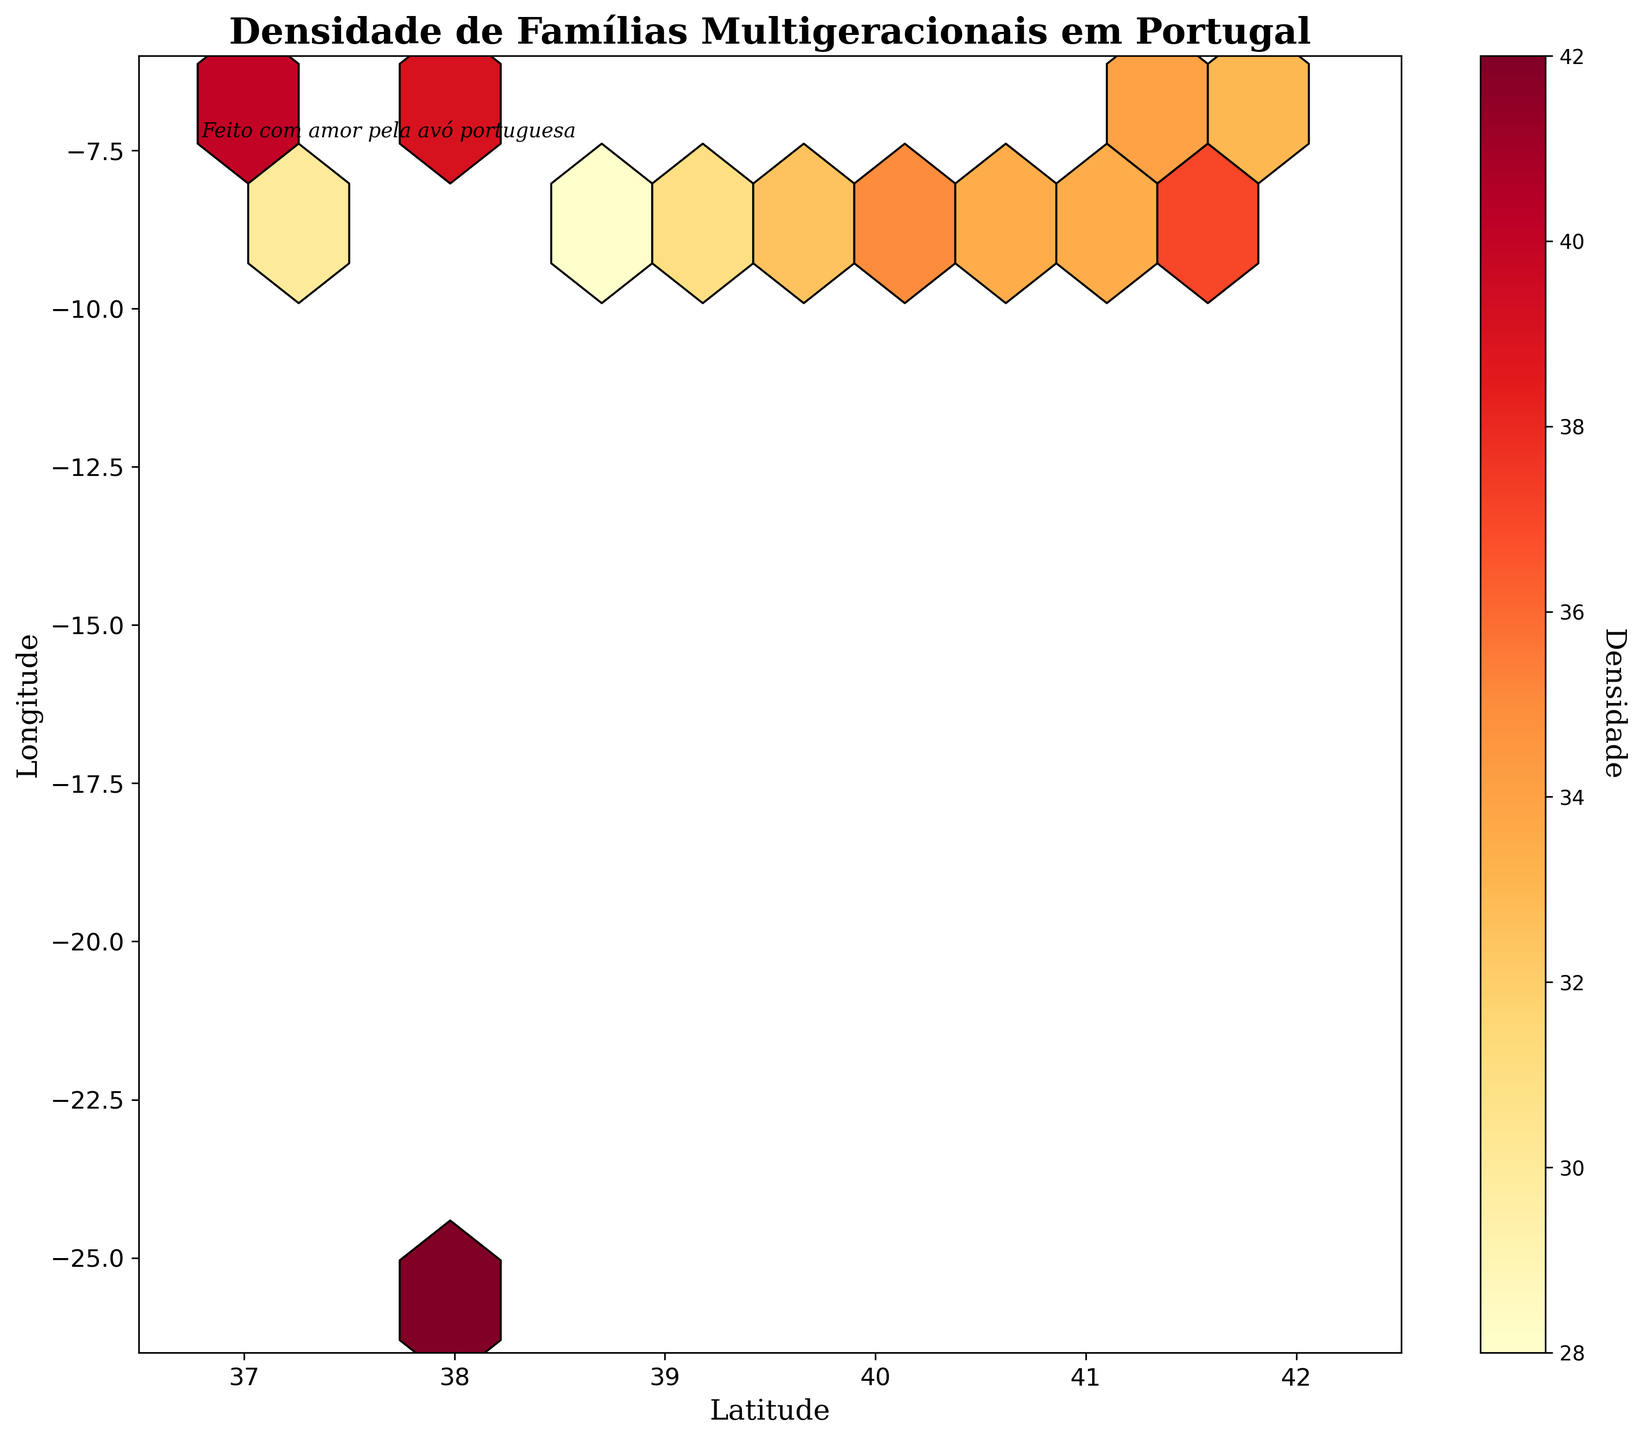Qual é o título do gráfico? O título do gráfico está localizado na parte superior do gráfico e é "Densidade de Famílias Multigeracionais em Portugal".
Answer: Densidade de Famílias Multigeracionais em Portugal Quais são os eixos do gráfico? Os eixos têm rótulos: o eixo horizontal (x) é a Latitude e o eixo vertical (y) é a Longitude.
Answer: Latitude (x), Longitude (y) Qual é o intervalo da Latitude no gráfico? O gráfico mostra a Latitude no eixo x com um intervalo de 36.5 a 42.5.
Answer: 36.5 a 42.5 Qual é a cor predominante nas regiões com maior densidade? A cor predominante nas regiões com maior densidade é um tom mais escuro ou âmbar no cmap 'YlOrRd', indicando maior densidade.
Answer: Âmbar mais escuro Qual região tem a maior densidade de famílias multigeracionais? A região em torno das coordenadas (37.75, -25.67) na figura apresenta a densidade mais alta, mostrada por um tom mais escuro na paleta de cores do mapa de aquecimento (hexbin).
Answer: (37.75, -25.67) Quais são as coordenadas da área com a densidade mais baixa? A menor densidade está representada na área em tom mais claro ou amarelo, que está próxima das coordenadas (38.71, -9.42).
Answer: (38.71, -9.42) Qual é a densidade média das famílias multigeracionais nas regiões apresentadas no gráfico? A densidade média pode ser calculada somando todas as densidades e dividindo pelo número de dados: (32 + 28 + 35 + 40 + 38 + 30 + 33 + 29 + 36 + 31 + 42 + 27 + 34 + 37 + 39 + 32 + 30 + 35 + 28 + 33) / 20.
Answer: 33.25 Há mais regiões com densidade maior ou menor que 35? Contando as regiões com densidade maior que 35 (40, 38, 42, 36, 34, 37, 39, 35) e as regiões com densidade menor ou igual a 35 (32, 28, 35, 30, 33, 29, 31, 27, 32, 30, 28, 33), há mais regiões com densidade menor ou igual a 35.
Answer: Menor ou igual a 35 Como a densidade de famílias multigeracionais varia ao longo do eixo y (Longitude)? A densidade varia com maior concentração em coordenadas mais baixas próximo a -25.67, com valores mais altos de densidade, e uma dispersão variada em outras latitudes.
Answer: Valores mais altos em coordenadas mais baixas Qual é a importância das cores na interpretação da densidade no gráfico? As cores no gráfico indicam densidade, onde tons mais escuros e diferentes de âmbar representam densidade maior e amarelos representam menor densidade, ajudando a interpretar visualmente as áreas com mais aglomeração de famílias multigeracionais.
Answer: Indica densidade 